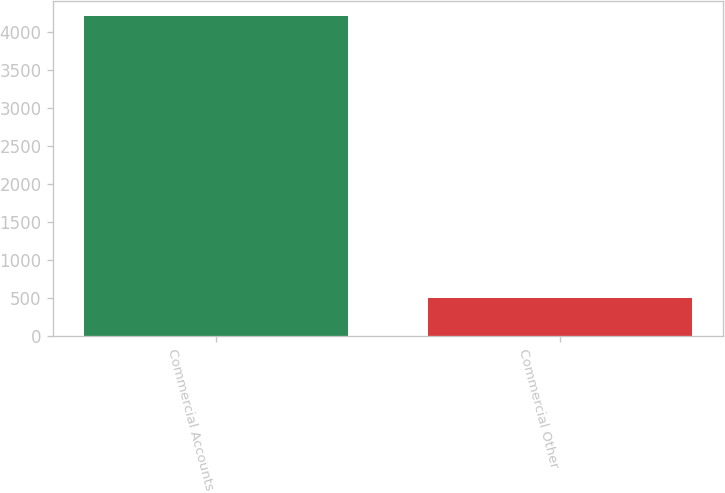Convert chart. <chart><loc_0><loc_0><loc_500><loc_500><bar_chart><fcel>Commercial Accounts<fcel>Commercial Other<nl><fcel>4210<fcel>506<nl></chart> 